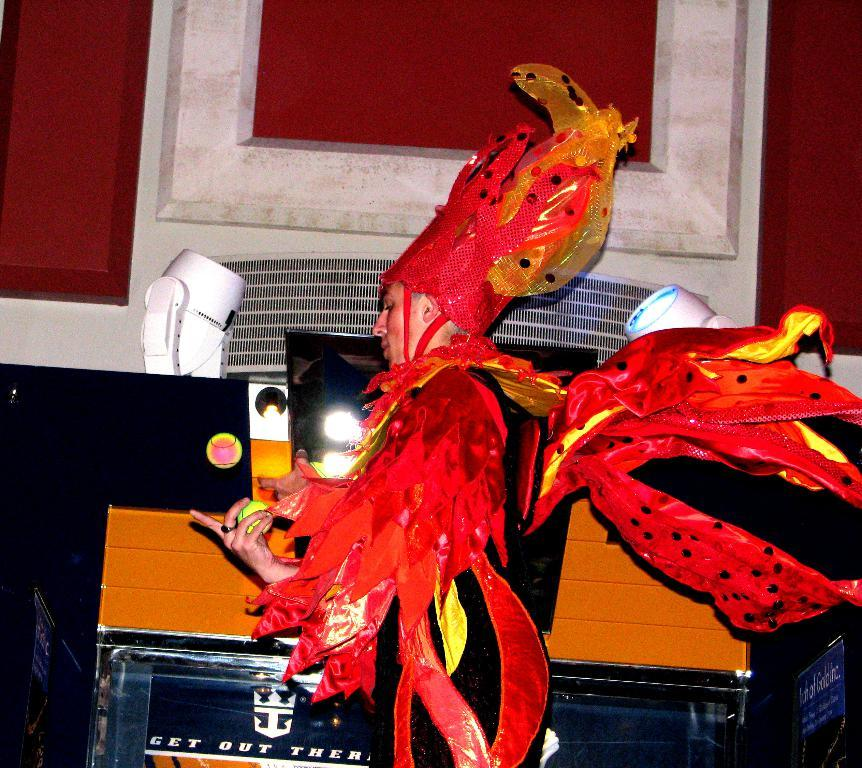What is the person in the image doing? The person is standing in the image. What is the person wearing? The person is wearing a costume. What is the person holding? The person is holding a ball. What can be seen in the image that provides illumination? There are lights visible in the image. What type of decorations are present in the image? There are banners in the image. What else can be seen in the image besides the person and the banners? There are objects in the image. What is visible in the background of the image? There is a wall in the background of the image. Can you tell me how many bees are sitting on the pie in the image? There is no pie or bees present in the image. What type of feather is being used as a prop by the person in the image? There is no feather visible in the image. 